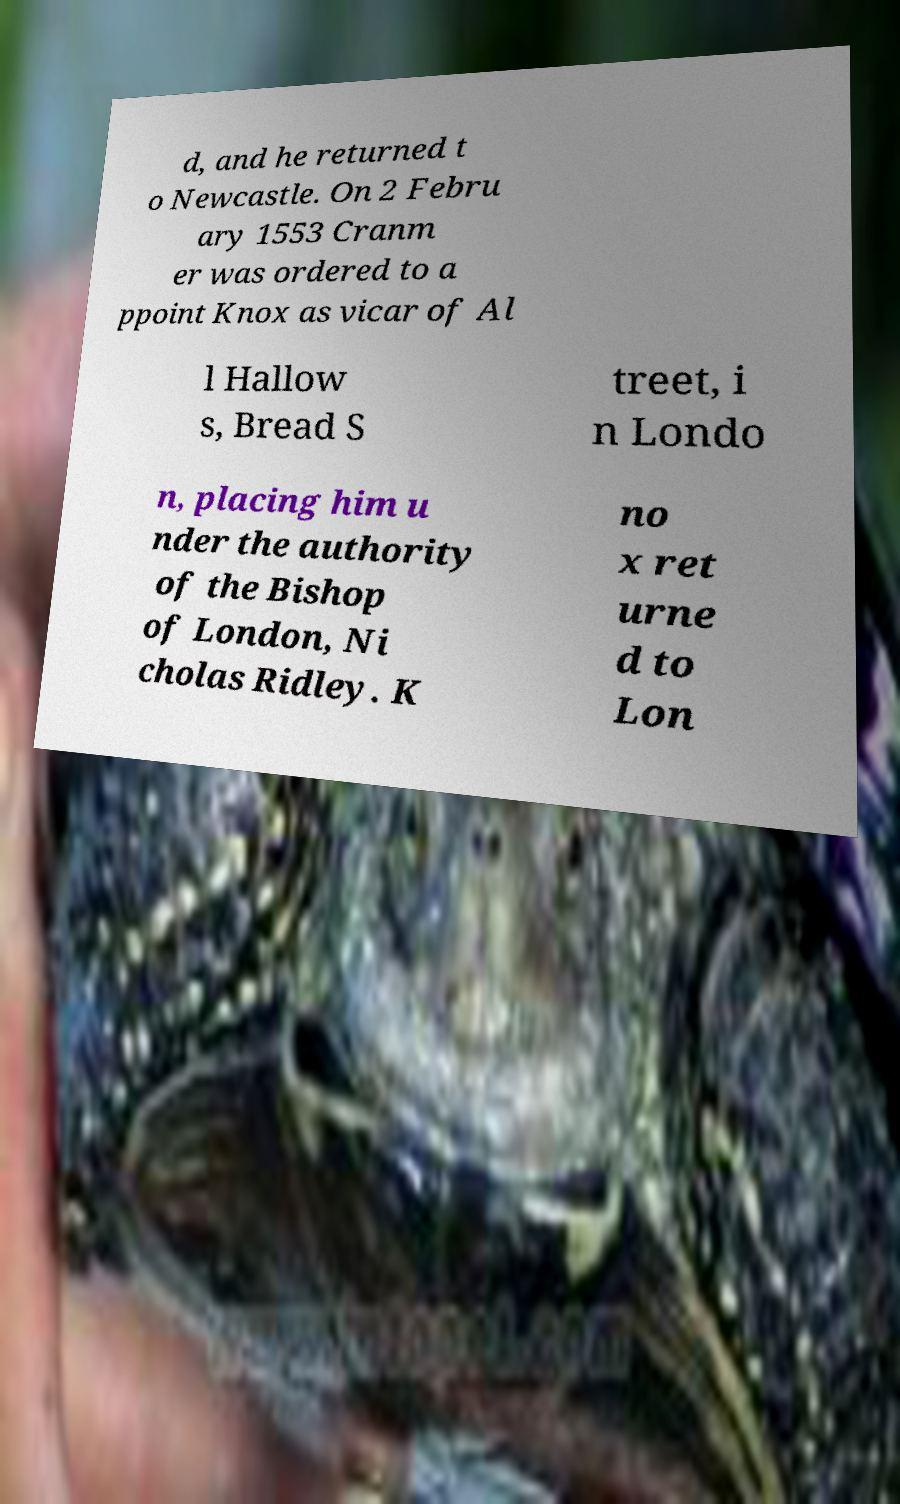Could you assist in decoding the text presented in this image and type it out clearly? d, and he returned t o Newcastle. On 2 Febru ary 1553 Cranm er was ordered to a ppoint Knox as vicar of Al l Hallow s, Bread S treet, i n Londo n, placing him u nder the authority of the Bishop of London, Ni cholas Ridley. K no x ret urne d to Lon 